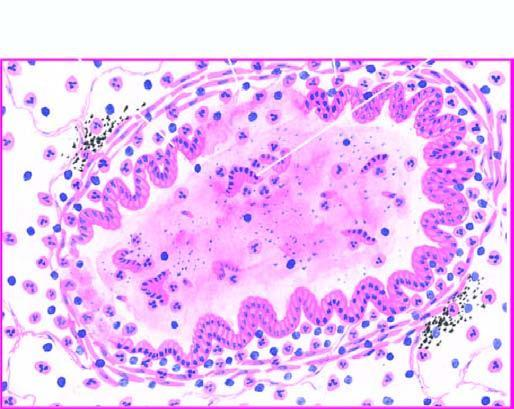s the deposition sloughed off at places with exudate of muco-pus in the lumen?
Answer the question using a single word or phrase. No 